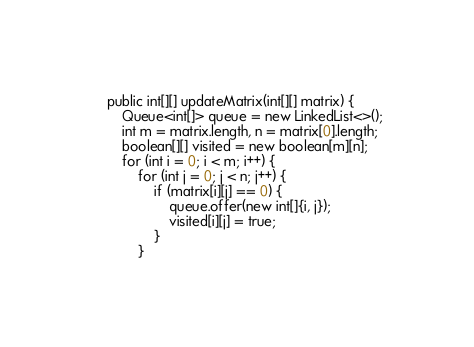Convert code to text. <code><loc_0><loc_0><loc_500><loc_500><_Java_>    public int[][] updateMatrix(int[][] matrix) {
        Queue<int[]> queue = new LinkedList<>();
        int m = matrix.length, n = matrix[0].length;
        boolean[][] visited = new boolean[m][n];
        for (int i = 0; i < m; i++) {
            for (int j = 0; j < n; j++) {
                if (matrix[i][j] == 0) {
                    queue.offer(new int[]{i, j});
                    visited[i][j] = true;
                }
            }</code> 